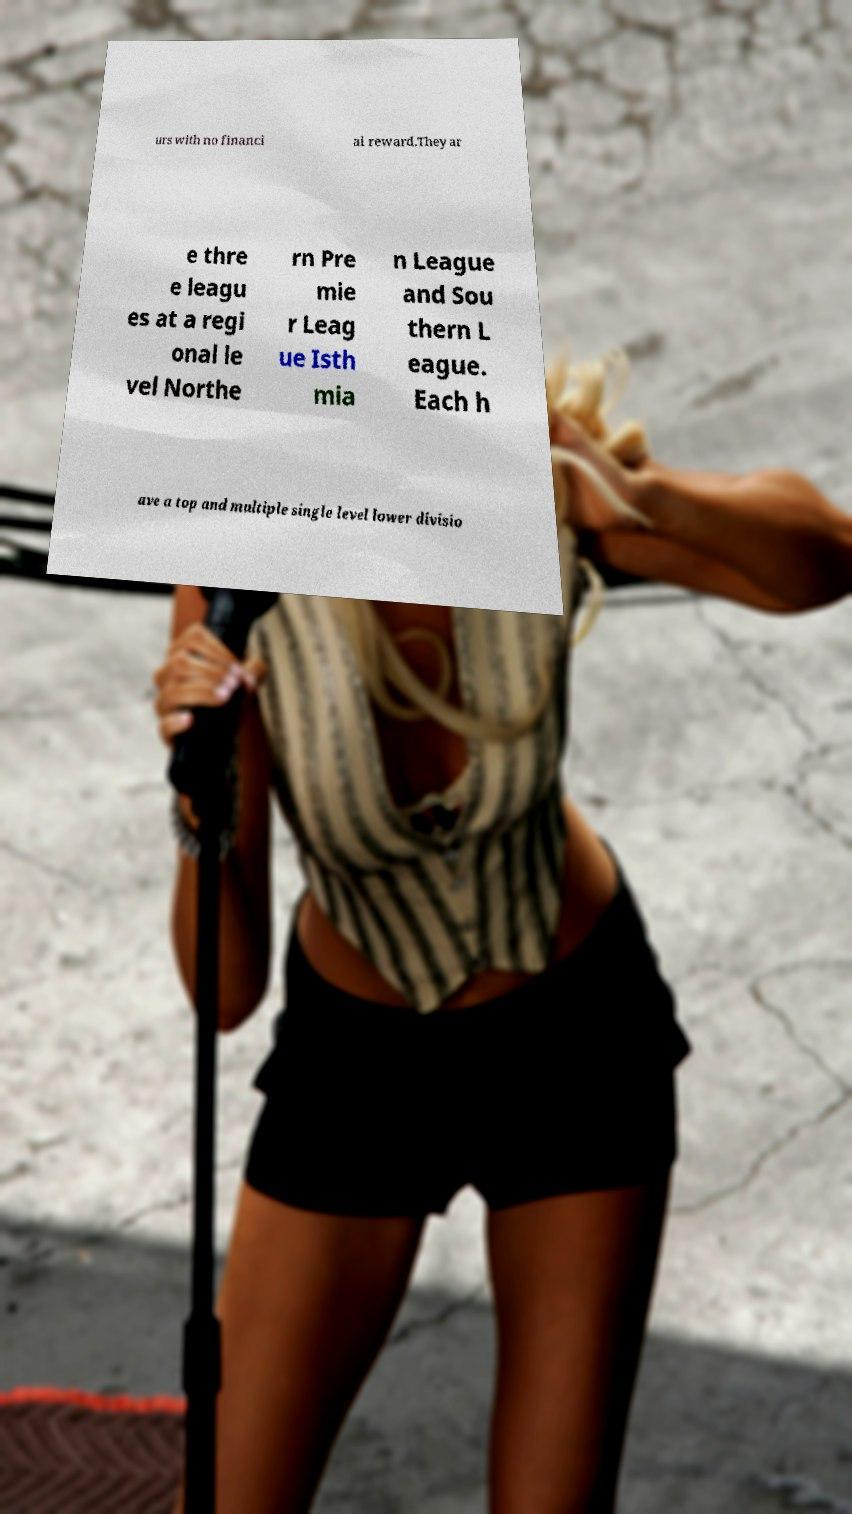Please read and relay the text visible in this image. What does it say? urs with no financi al reward.They ar e thre e leagu es at a regi onal le vel Northe rn Pre mie r Leag ue Isth mia n League and Sou thern L eague. Each h ave a top and multiple single level lower divisio 